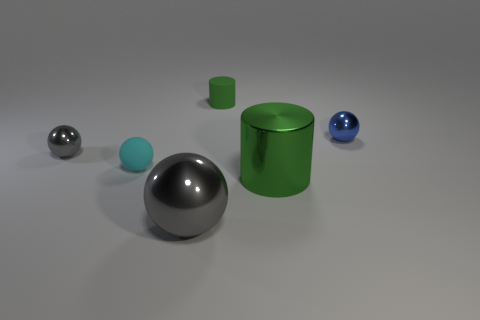Are there any green shiny objects of the same shape as the green rubber thing?
Make the answer very short. Yes. Do the blue metal thing and the green metallic thing have the same shape?
Your answer should be compact. No. What number of tiny things are green metal objects or metal objects?
Give a very brief answer. 2. Is the number of big green things greater than the number of small cyan metal objects?
Provide a succinct answer. Yes. The gray sphere that is made of the same material as the tiny gray object is what size?
Your response must be concise. Large. Do the green cylinder that is behind the blue metallic ball and the gray metallic thing that is right of the tiny cyan matte thing have the same size?
Your answer should be compact. No. How many things are big metal objects that are behind the large gray thing or green rubber things?
Offer a terse response. 2. Is the number of big green objects less than the number of blue cylinders?
Provide a succinct answer. No. What is the shape of the tiny rubber thing in front of the small shiny thing on the right side of the tiny metallic ball in front of the small blue thing?
Ensure brevity in your answer.  Sphere. What is the shape of the small shiny object that is the same color as the large ball?
Offer a very short reply. Sphere. 